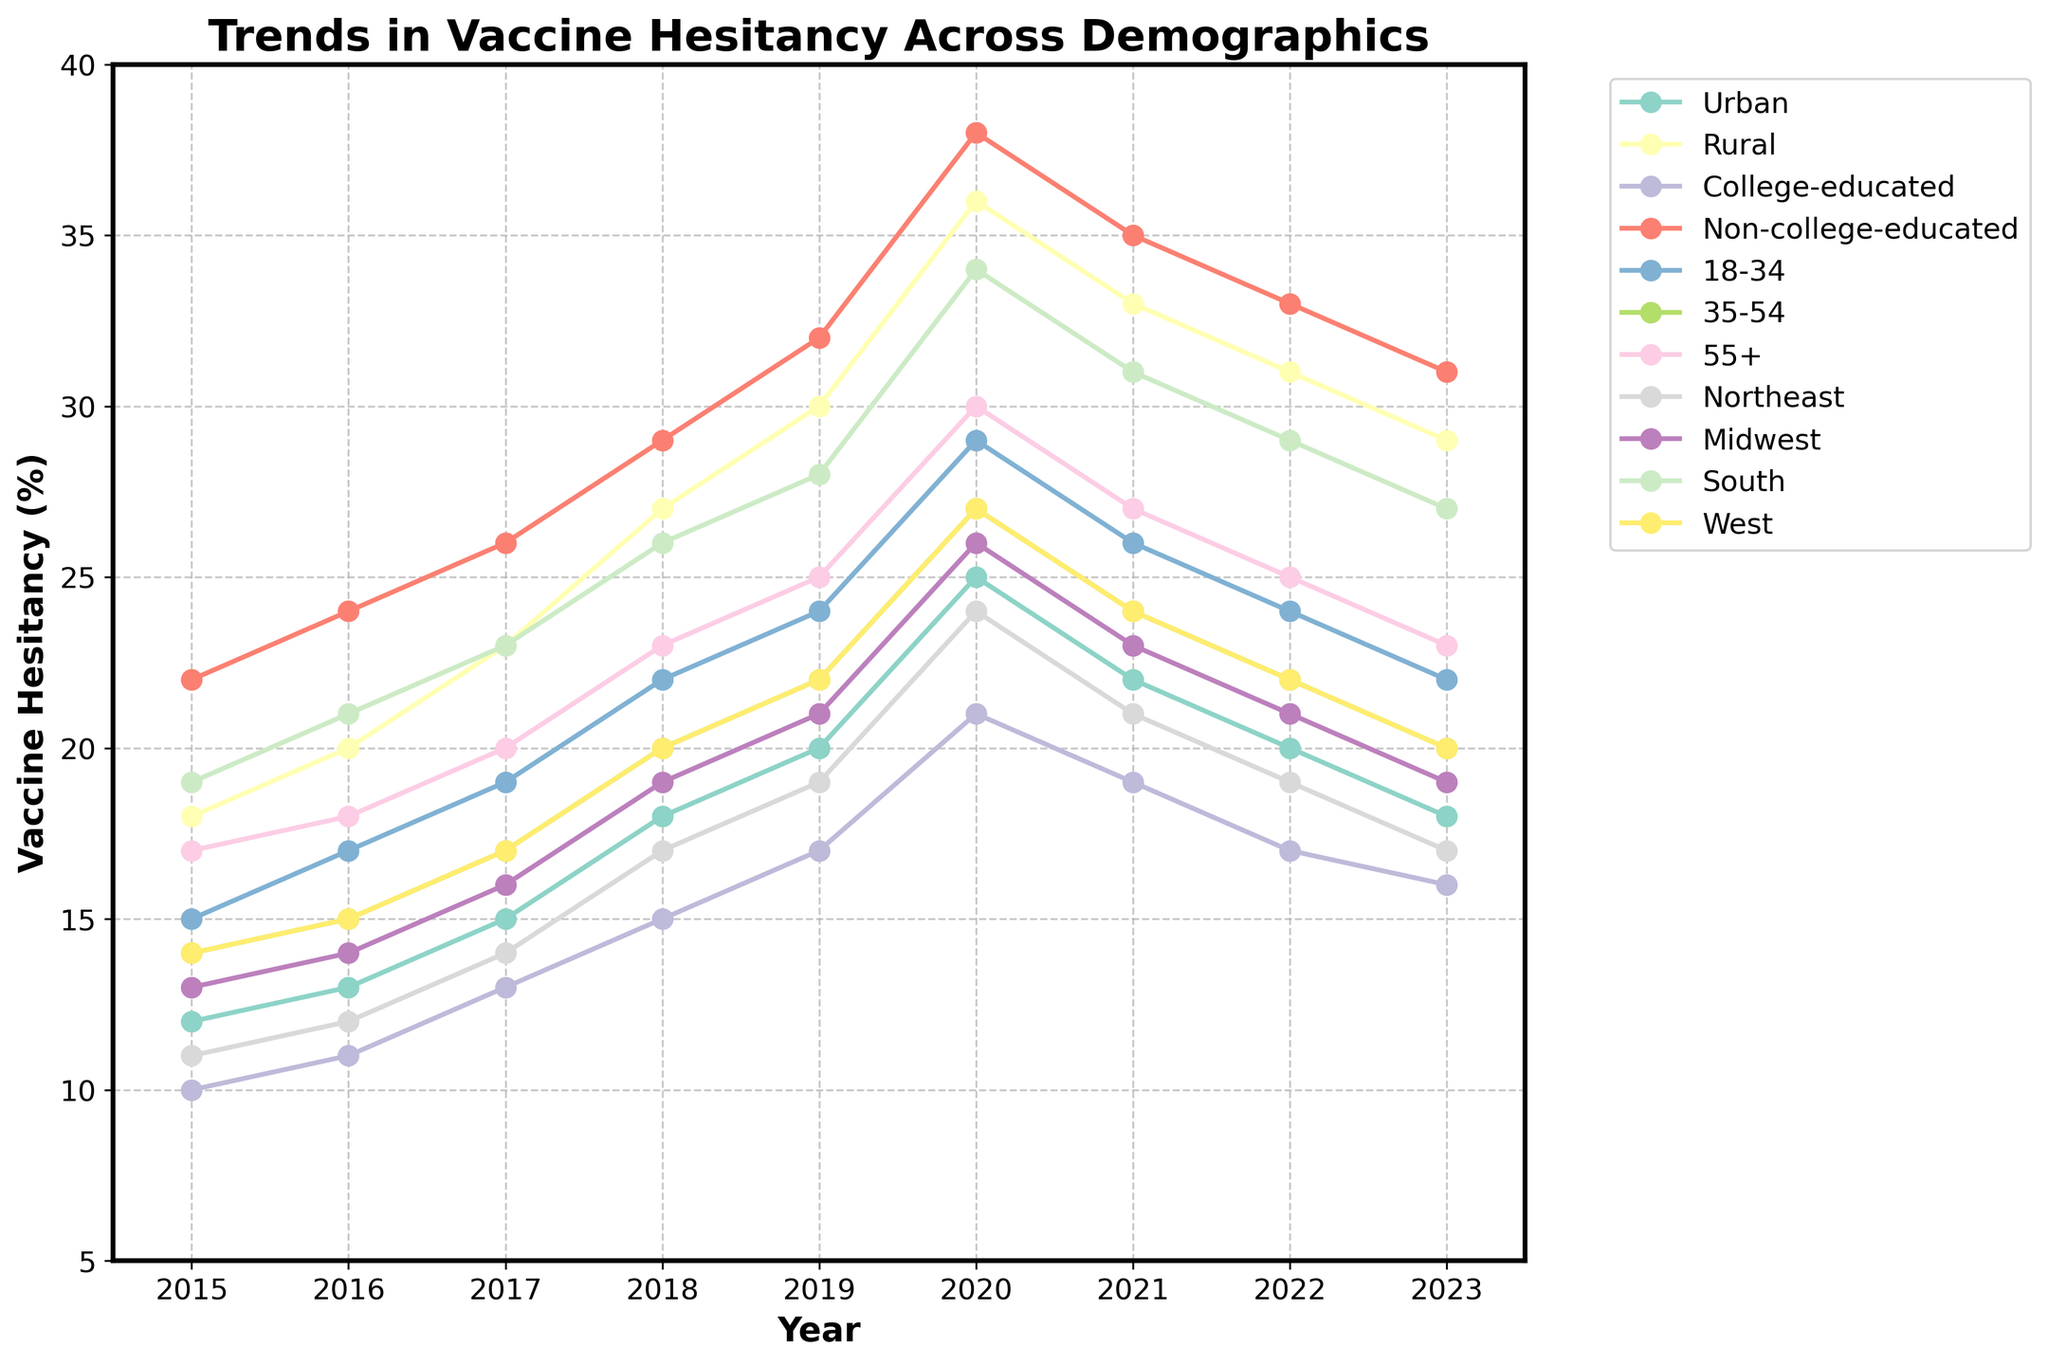Which region experienced the highest vaccine hesitancy in 2020? Looking at the figure, the highest point for any region in 2020 appears to be the South.
Answer: South Which demographic group showed the most significant decrease in vaccine hesitancy from 2020 to 2023? Observing the data, the College-educated group had a decline from 21% in 2020 to 16% in 2023, marking a 5% decrease, which is the largest drop among demographics.
Answer: College-educated What's the average vaccine hesitancy for the Rural group from 2015 to 2023? Adding all the percentages for the Rural group from 2015 (18), 2016 (20), 2017 (23), 2018 (27), 2019 (30), 2020 (36), 2021 (33), 2022 (31), and 2023 (29) gives a total of 247. Dividing by 9 years, the average is 27.44%.
Answer: 27.44% Which age group had the highest level of vaccine hesitancy in 2019? According to the figure, the bars indicate that individuals aged 55+ had the highest vaccine hesitancy in 2019.
Answer: 55+ In 2018, how did the vaccine hesitancy of the College-educated group compare to that of the Non-college-educated group? Checking the line for 2018, College-educated had a hesitancy of 15%, while Non-college-educated had 29%. Hence, Non-college-educated had a higher hesitancy by 14%.
Answer: Non-college-educated is 14% higher Which region displayed the least variation in vaccine hesitancy between 2015 and 2023? By analyzing the height difference for each year, the Northeast had the least variation, particularly between 11% in 2015 and 17% in 2023, showing relatively small fluctuations over the years.
Answer: Northeast Comparing the hesitancy rates, was the hesitancy higher for individuals aged 18-34 or the West region in 2023? Observing 2023 data, individuals aged 18-34 had a hesitancy of 22%, while the West region had 20%. Thus, hesitancy was higher among individuals aged 18-34 by 2%.
Answer: 18-34 By what percentage did vaccine hesitancy in the Midwest region change from 2020 to 2021? In 2020, the Midwest had hesitancy at 26%, and in 2021, it dropped to 23%. The difference is 26% - 23% = 3%, showing a 3% decrease.
Answer: 3% decrease What is the overall trend of vaccine hesitancy among people aged 35-54 from 2015 to 2023? Tracking the data points, the vaccine hesitancy for the 35-54 age group began at 14% in 2015, increasing steadily until 2020 peaking at 27%, and subsequently declining to 20% in 2023. Thus, it shows an initial increase followed by a decrease.
Answer: Initial increase, then decrease 